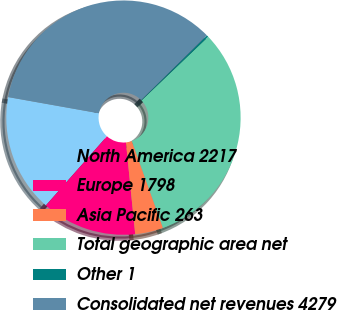<chart> <loc_0><loc_0><loc_500><loc_500><pie_chart><fcel>North America 2217<fcel>Europe 1798<fcel>Asia Pacific 263<fcel>Total geographic area net<fcel>Other 1<fcel>Consolidated net revenues 4279<nl><fcel>16.29%<fcel>13.12%<fcel>3.88%<fcel>31.66%<fcel>0.24%<fcel>34.82%<nl></chart> 